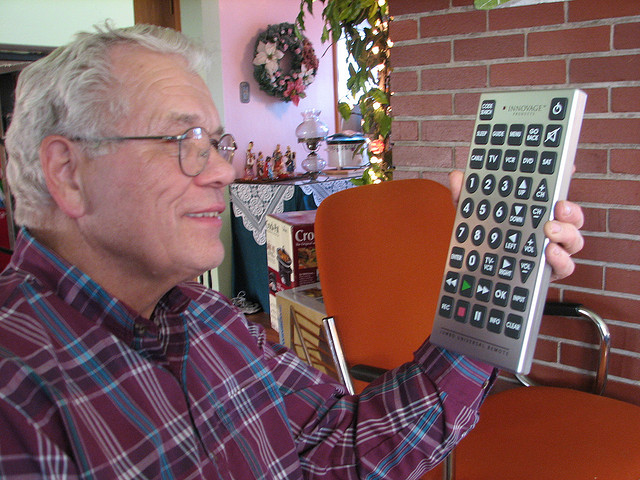Please identify all text content in this image. 7 8 TV 3 Cro NO OK 0 9 6 5 4 2 1 